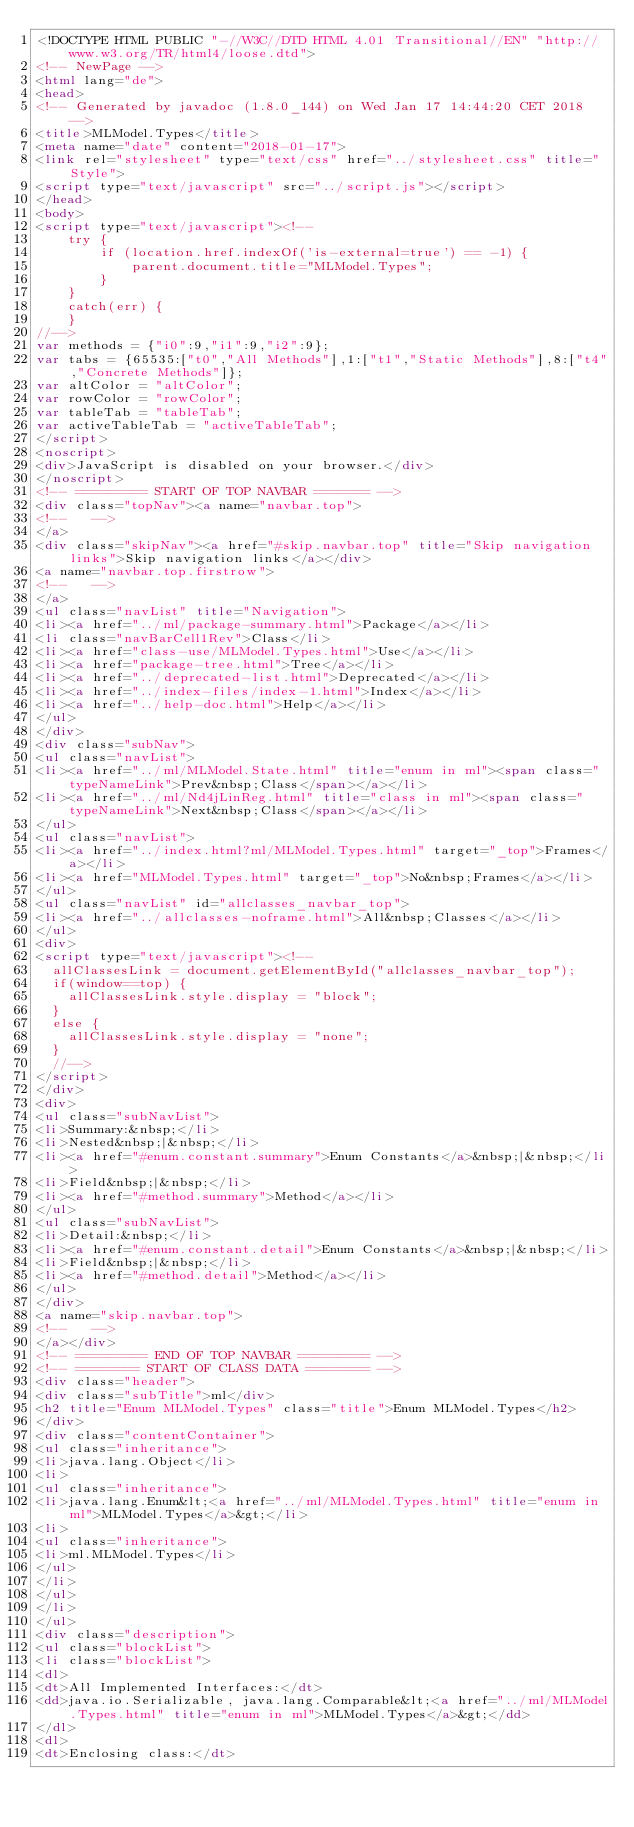<code> <loc_0><loc_0><loc_500><loc_500><_HTML_><!DOCTYPE HTML PUBLIC "-//W3C//DTD HTML 4.01 Transitional//EN" "http://www.w3.org/TR/html4/loose.dtd">
<!-- NewPage -->
<html lang="de">
<head>
<!-- Generated by javadoc (1.8.0_144) on Wed Jan 17 14:44:20 CET 2018 -->
<title>MLModel.Types</title>
<meta name="date" content="2018-01-17">
<link rel="stylesheet" type="text/css" href="../stylesheet.css" title="Style">
<script type="text/javascript" src="../script.js"></script>
</head>
<body>
<script type="text/javascript"><!--
    try {
        if (location.href.indexOf('is-external=true') == -1) {
            parent.document.title="MLModel.Types";
        }
    }
    catch(err) {
    }
//-->
var methods = {"i0":9,"i1":9,"i2":9};
var tabs = {65535:["t0","All Methods"],1:["t1","Static Methods"],8:["t4","Concrete Methods"]};
var altColor = "altColor";
var rowColor = "rowColor";
var tableTab = "tableTab";
var activeTableTab = "activeTableTab";
</script>
<noscript>
<div>JavaScript is disabled on your browser.</div>
</noscript>
<!-- ========= START OF TOP NAVBAR ======= -->
<div class="topNav"><a name="navbar.top">
<!--   -->
</a>
<div class="skipNav"><a href="#skip.navbar.top" title="Skip navigation links">Skip navigation links</a></div>
<a name="navbar.top.firstrow">
<!--   -->
</a>
<ul class="navList" title="Navigation">
<li><a href="../ml/package-summary.html">Package</a></li>
<li class="navBarCell1Rev">Class</li>
<li><a href="class-use/MLModel.Types.html">Use</a></li>
<li><a href="package-tree.html">Tree</a></li>
<li><a href="../deprecated-list.html">Deprecated</a></li>
<li><a href="../index-files/index-1.html">Index</a></li>
<li><a href="../help-doc.html">Help</a></li>
</ul>
</div>
<div class="subNav">
<ul class="navList">
<li><a href="../ml/MLModel.State.html" title="enum in ml"><span class="typeNameLink">Prev&nbsp;Class</span></a></li>
<li><a href="../ml/Nd4jLinReg.html" title="class in ml"><span class="typeNameLink">Next&nbsp;Class</span></a></li>
</ul>
<ul class="navList">
<li><a href="../index.html?ml/MLModel.Types.html" target="_top">Frames</a></li>
<li><a href="MLModel.Types.html" target="_top">No&nbsp;Frames</a></li>
</ul>
<ul class="navList" id="allclasses_navbar_top">
<li><a href="../allclasses-noframe.html">All&nbsp;Classes</a></li>
</ul>
<div>
<script type="text/javascript"><!--
  allClassesLink = document.getElementById("allclasses_navbar_top");
  if(window==top) {
    allClassesLink.style.display = "block";
  }
  else {
    allClassesLink.style.display = "none";
  }
  //-->
</script>
</div>
<div>
<ul class="subNavList">
<li>Summary:&nbsp;</li>
<li>Nested&nbsp;|&nbsp;</li>
<li><a href="#enum.constant.summary">Enum Constants</a>&nbsp;|&nbsp;</li>
<li>Field&nbsp;|&nbsp;</li>
<li><a href="#method.summary">Method</a></li>
</ul>
<ul class="subNavList">
<li>Detail:&nbsp;</li>
<li><a href="#enum.constant.detail">Enum Constants</a>&nbsp;|&nbsp;</li>
<li>Field&nbsp;|&nbsp;</li>
<li><a href="#method.detail">Method</a></li>
</ul>
</div>
<a name="skip.navbar.top">
<!--   -->
</a></div>
<!-- ========= END OF TOP NAVBAR ========= -->
<!-- ======== START OF CLASS DATA ======== -->
<div class="header">
<div class="subTitle">ml</div>
<h2 title="Enum MLModel.Types" class="title">Enum MLModel.Types</h2>
</div>
<div class="contentContainer">
<ul class="inheritance">
<li>java.lang.Object</li>
<li>
<ul class="inheritance">
<li>java.lang.Enum&lt;<a href="../ml/MLModel.Types.html" title="enum in ml">MLModel.Types</a>&gt;</li>
<li>
<ul class="inheritance">
<li>ml.MLModel.Types</li>
</ul>
</li>
</ul>
</li>
</ul>
<div class="description">
<ul class="blockList">
<li class="blockList">
<dl>
<dt>All Implemented Interfaces:</dt>
<dd>java.io.Serializable, java.lang.Comparable&lt;<a href="../ml/MLModel.Types.html" title="enum in ml">MLModel.Types</a>&gt;</dd>
</dl>
<dl>
<dt>Enclosing class:</dt></code> 